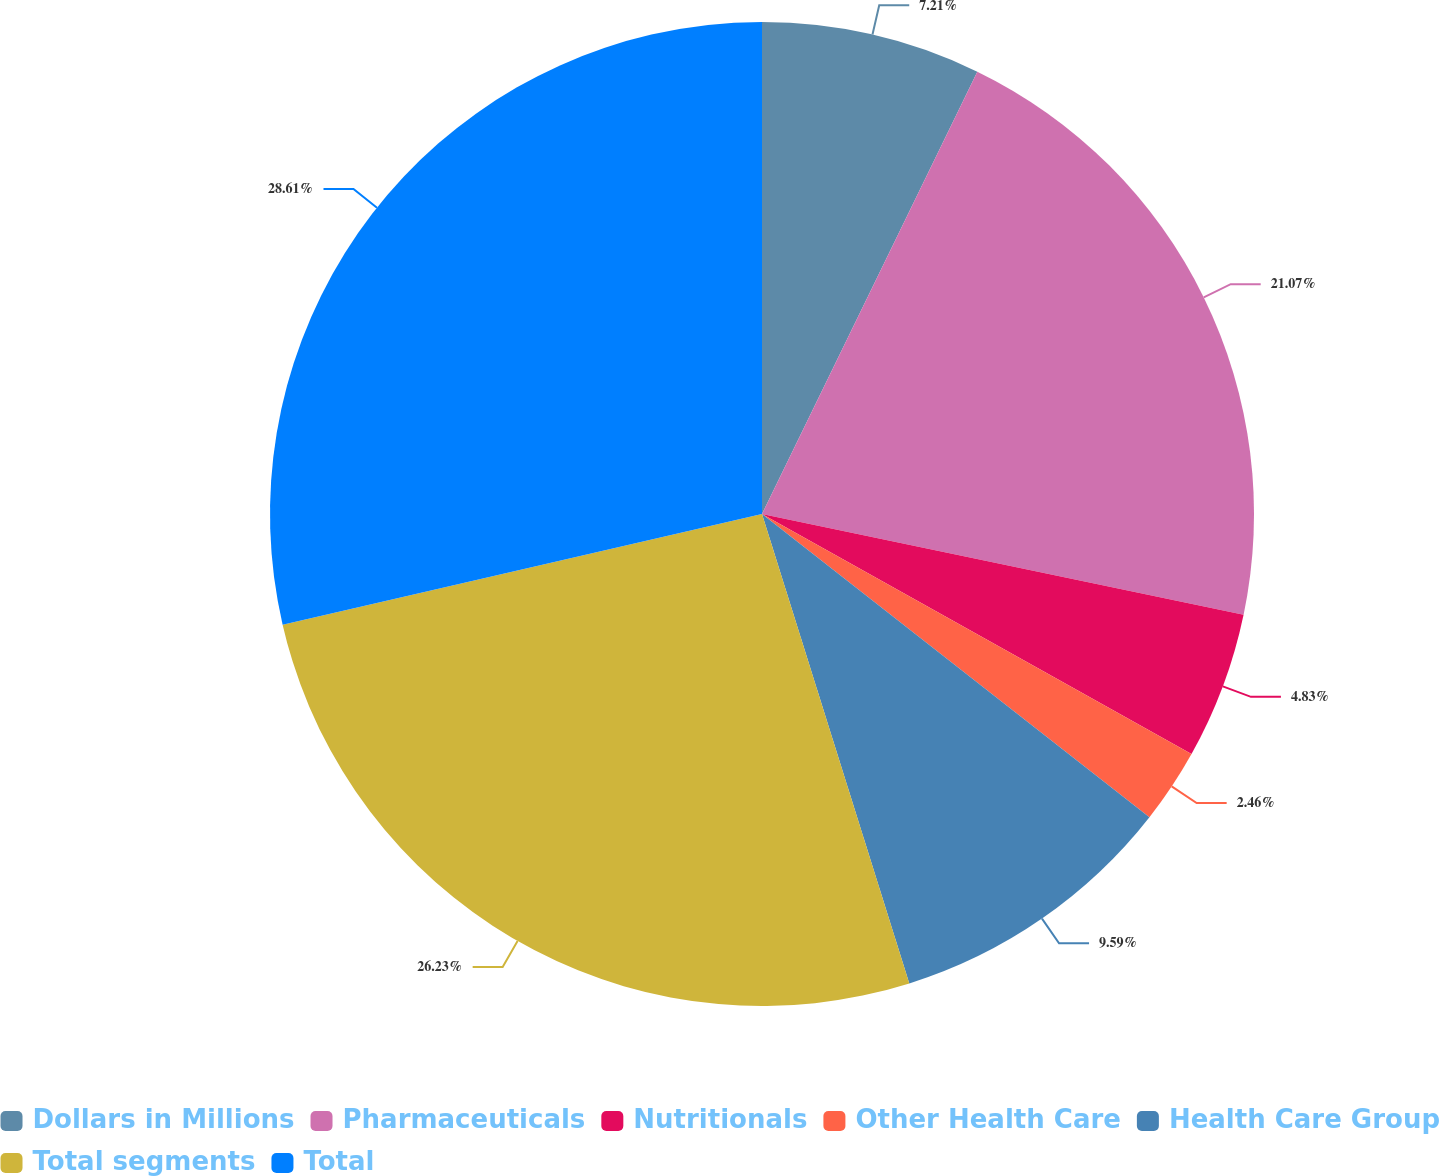<chart> <loc_0><loc_0><loc_500><loc_500><pie_chart><fcel>Dollars in Millions<fcel>Pharmaceuticals<fcel>Nutritionals<fcel>Other Health Care<fcel>Health Care Group<fcel>Total segments<fcel>Total<nl><fcel>7.21%<fcel>21.07%<fcel>4.83%<fcel>2.46%<fcel>9.59%<fcel>26.23%<fcel>28.61%<nl></chart> 